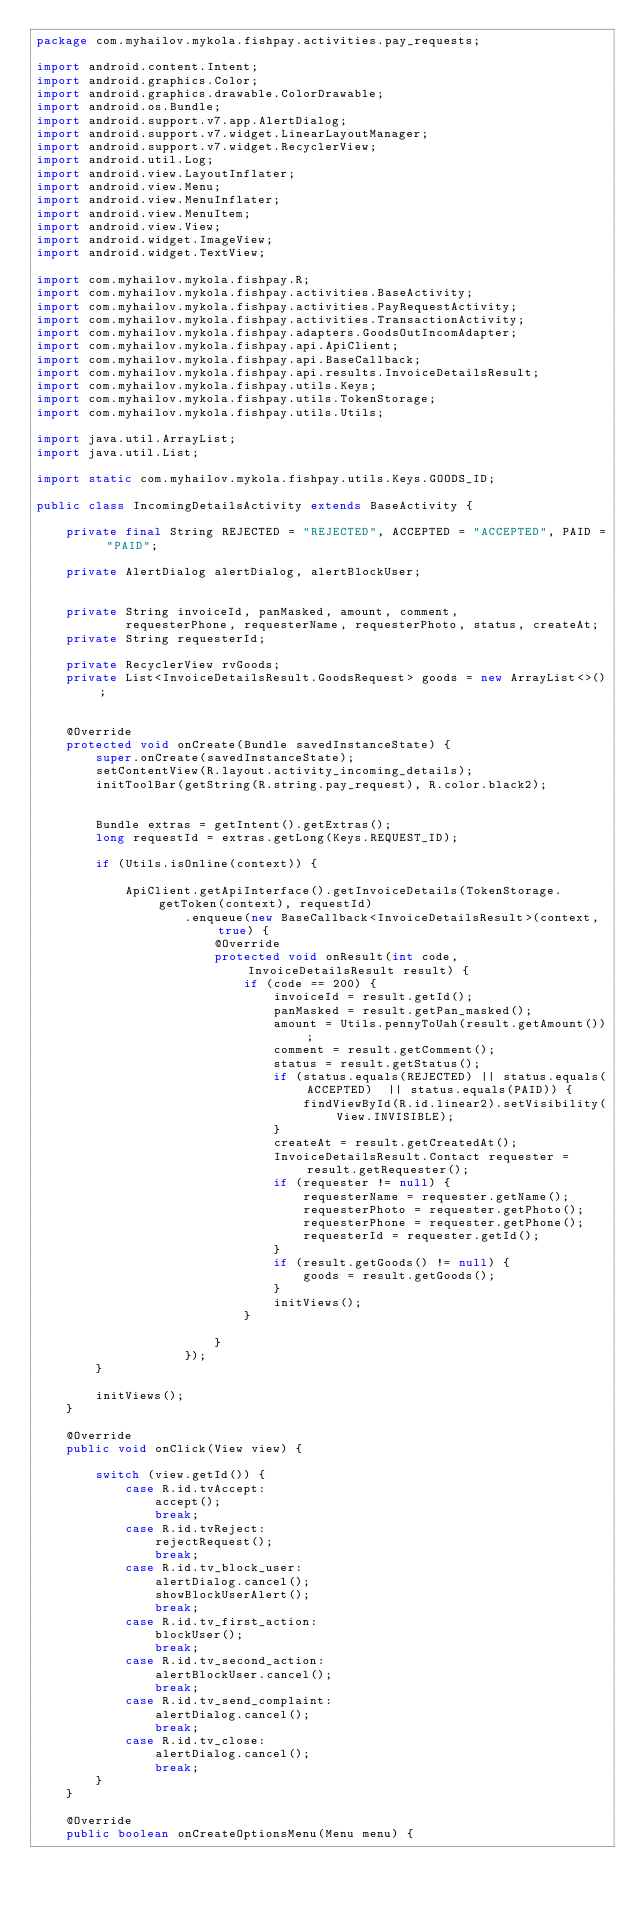<code> <loc_0><loc_0><loc_500><loc_500><_Java_>package com.myhailov.mykola.fishpay.activities.pay_requests;

import android.content.Intent;
import android.graphics.Color;
import android.graphics.drawable.ColorDrawable;
import android.os.Bundle;
import android.support.v7.app.AlertDialog;
import android.support.v7.widget.LinearLayoutManager;
import android.support.v7.widget.RecyclerView;
import android.util.Log;
import android.view.LayoutInflater;
import android.view.Menu;
import android.view.MenuInflater;
import android.view.MenuItem;
import android.view.View;
import android.widget.ImageView;
import android.widget.TextView;

import com.myhailov.mykola.fishpay.R;
import com.myhailov.mykola.fishpay.activities.BaseActivity;
import com.myhailov.mykola.fishpay.activities.PayRequestActivity;
import com.myhailov.mykola.fishpay.activities.TransactionActivity;
import com.myhailov.mykola.fishpay.adapters.GoodsOutIncomAdapter;
import com.myhailov.mykola.fishpay.api.ApiClient;
import com.myhailov.mykola.fishpay.api.BaseCallback;
import com.myhailov.mykola.fishpay.api.results.InvoiceDetailsResult;
import com.myhailov.mykola.fishpay.utils.Keys;
import com.myhailov.mykola.fishpay.utils.TokenStorage;
import com.myhailov.mykola.fishpay.utils.Utils;

import java.util.ArrayList;
import java.util.List;

import static com.myhailov.mykola.fishpay.utils.Keys.GOODS_ID;

public class IncomingDetailsActivity extends BaseActivity {

    private final String REJECTED = "REJECTED", ACCEPTED = "ACCEPTED", PAID = "PAID";

    private AlertDialog alertDialog, alertBlockUser;


    private String invoiceId, panMasked, amount, comment,
            requesterPhone, requesterName, requesterPhoto, status, createAt;
    private String requesterId;

    private RecyclerView rvGoods;
    private List<InvoiceDetailsResult.GoodsRequest> goods = new ArrayList<>();


    @Override
    protected void onCreate(Bundle savedInstanceState) {
        super.onCreate(savedInstanceState);
        setContentView(R.layout.activity_incoming_details);
        initToolBar(getString(R.string.pay_request), R.color.black2);


        Bundle extras = getIntent().getExtras();
        long requestId = extras.getLong(Keys.REQUEST_ID);

        if (Utils.isOnline(context)) {

            ApiClient.getApiInterface().getInvoiceDetails(TokenStorage.getToken(context), requestId)
                    .enqueue(new BaseCallback<InvoiceDetailsResult>(context, true) {
                        @Override
                        protected void onResult(int code, InvoiceDetailsResult result) {
                            if (code == 200) {
                                invoiceId = result.getId();
                                panMasked = result.getPan_masked();
                                amount = Utils.pennyToUah(result.getAmount());
                                comment = result.getComment();
                                status = result.getStatus();
                                if (status.equals(REJECTED) || status.equals(ACCEPTED)  || status.equals(PAID)) {
                                    findViewById(R.id.linear2).setVisibility(View.INVISIBLE);
                                }
                                createAt = result.getCreatedAt();
                                InvoiceDetailsResult.Contact requester = result.getRequester();
                                if (requester != null) {
                                    requesterName = requester.getName();
                                    requesterPhoto = requester.getPhoto();
                                    requesterPhone = requester.getPhone();
                                    requesterId = requester.getId();
                                }
                                if (result.getGoods() != null) {
                                    goods = result.getGoods();
                                }
                                initViews();
                            }

                        }
                    });
        }

        initViews();
    }

    @Override
    public void onClick(View view) {

        switch (view.getId()) {
            case R.id.tvAccept:
                accept();
                break;
            case R.id.tvReject:
                rejectRequest();
                break;
            case R.id.tv_block_user:
                alertDialog.cancel();
                showBlockUserAlert();
                break;
            case R.id.tv_first_action:
                blockUser();
                break;
            case R.id.tv_second_action:
                alertBlockUser.cancel();
                break;
            case R.id.tv_send_complaint:
                alertDialog.cancel();
                break;
            case R.id.tv_close:
                alertDialog.cancel();
                break;
        }
    }

    @Override
    public boolean onCreateOptionsMenu(Menu menu) {</code> 